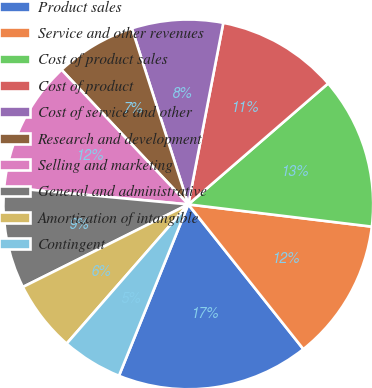Convert chart to OTSL. <chart><loc_0><loc_0><loc_500><loc_500><pie_chart><fcel>Product sales<fcel>Service and other revenues<fcel>Cost of product sales<fcel>Cost of product<fcel>Cost of service and other<fcel>Research and development<fcel>Selling and marketing<fcel>General and administrative<fcel>Amortization of intangible<fcel>Contingent<nl><fcel>16.81%<fcel>12.39%<fcel>13.27%<fcel>10.62%<fcel>7.97%<fcel>7.08%<fcel>11.5%<fcel>8.85%<fcel>6.2%<fcel>5.31%<nl></chart> 